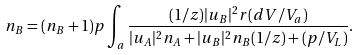Convert formula to latex. <formula><loc_0><loc_0><loc_500><loc_500>n _ { B } = ( n _ { B } + 1 ) p \int _ { a } \frac { ( 1 / z ) | u _ { B } | ^ { 2 } r ( d V / V _ { a } ) } { | u _ { A } | ^ { 2 } n _ { A } + | u _ { B } | ^ { 2 } n _ { B } ( 1 / z ) + ( p / V _ { L } ) } .</formula> 